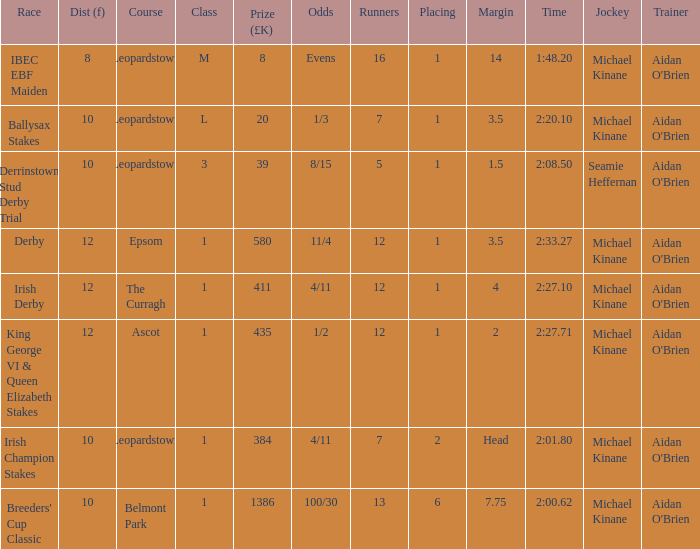Which distribution (f) features an irish derby race? 12.0. 